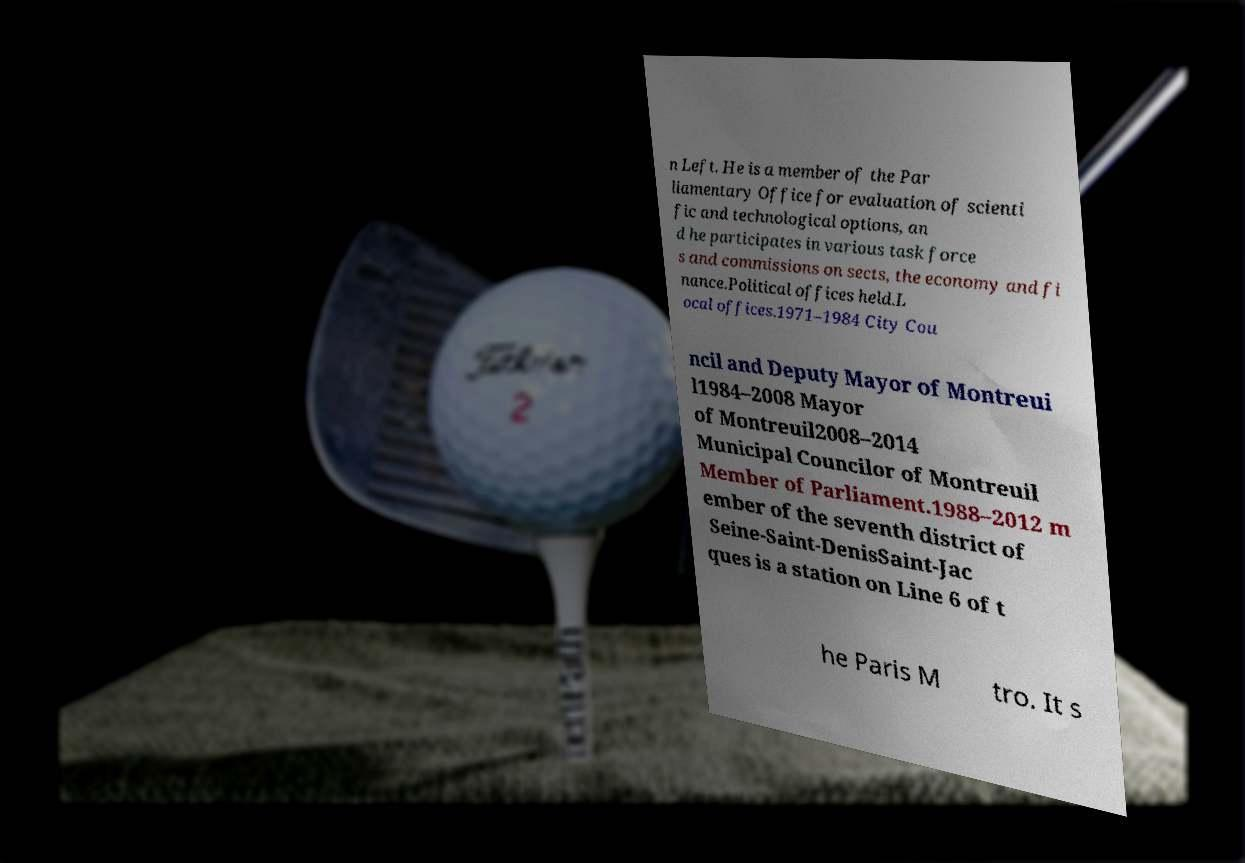Can you accurately transcribe the text from the provided image for me? n Left. He is a member of the Par liamentary Office for evaluation of scienti fic and technological options, an d he participates in various task force s and commissions on sects, the economy and fi nance.Political offices held.L ocal offices.1971–1984 City Cou ncil and Deputy Mayor of Montreui l1984–2008 Mayor of Montreuil2008–2014 Municipal Councilor of Montreuil Member of Parliament.1988–2012 m ember of the seventh district of Seine-Saint-DenisSaint-Jac ques is a station on Line 6 of t he Paris M tro. It s 